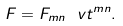Convert formula to latex. <formula><loc_0><loc_0><loc_500><loc_500>F = F _ { m n } \ v t ^ { m n } .</formula> 